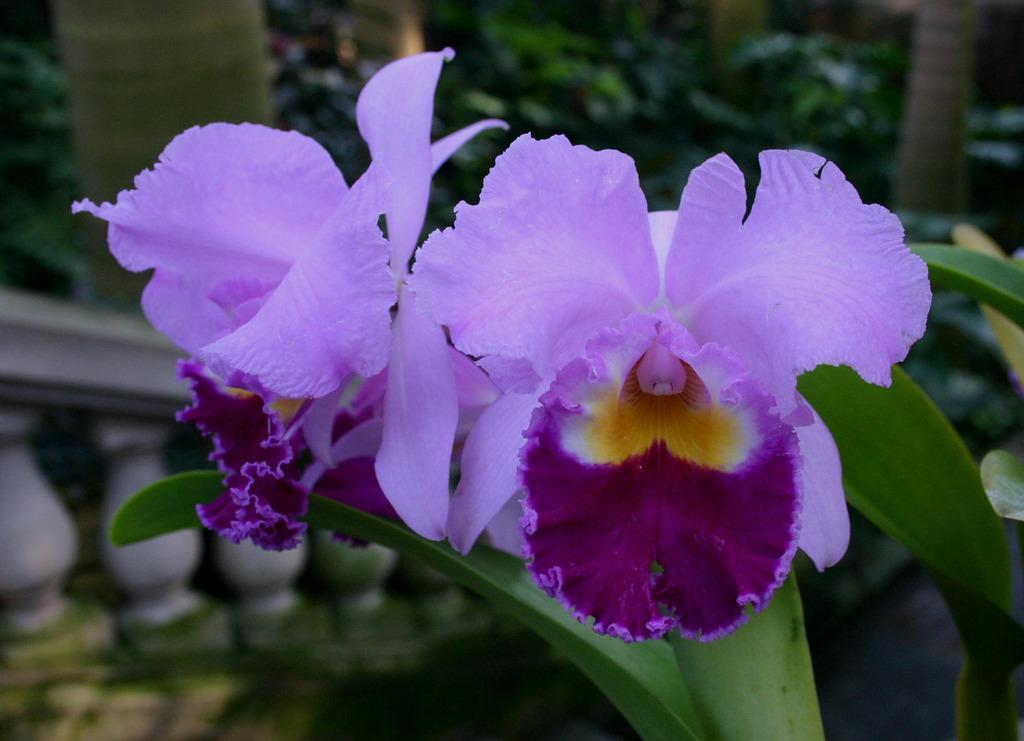In one or two sentences, can you explain what this image depicts? In this picture we can see flowers and in the background we can see a fence and trees. 